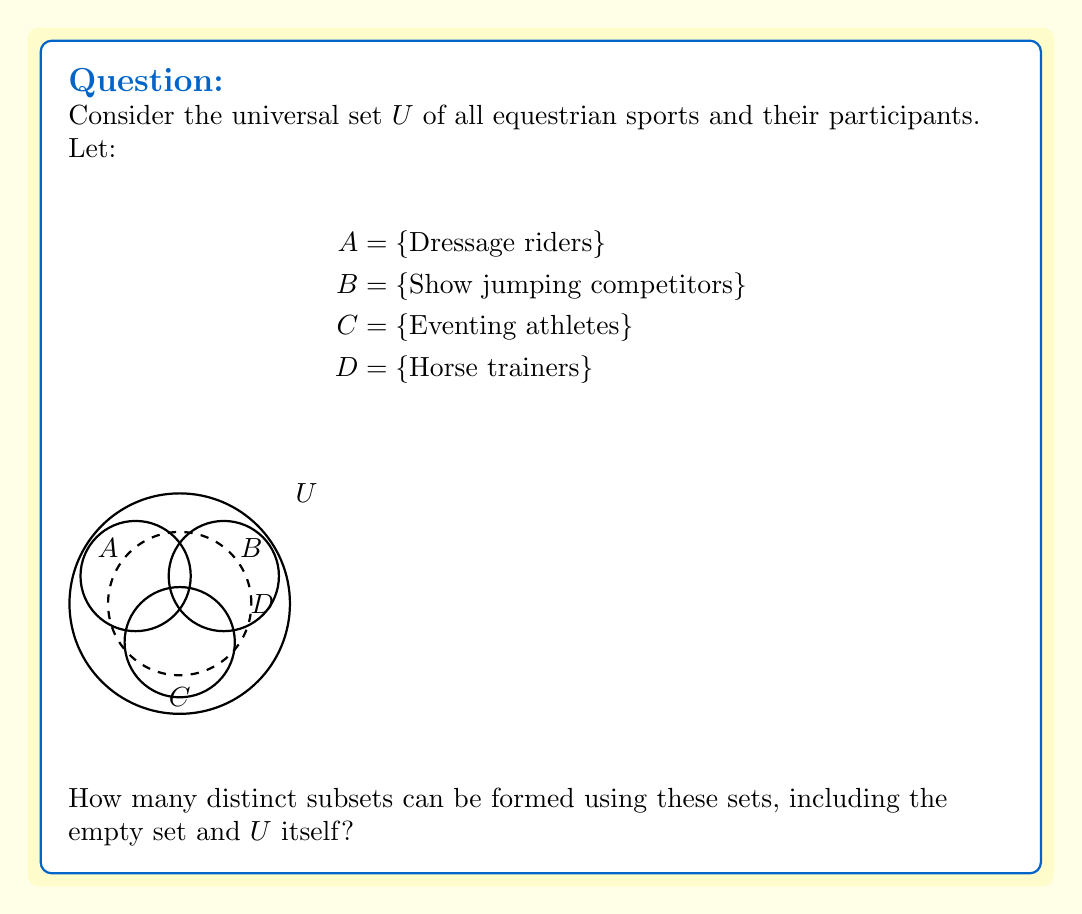Provide a solution to this math problem. To solve this problem, we need to use the concept of the power set in set theory.

Step 1: Identify the number of distinct sets we're working with.
We have 5 sets: $U$, $A$, $B$, $C$, and $D$.

Step 2: Understand that each of these sets can either be included or not included in a subset.

Step 3: Apply the formula for the number of subsets:
Number of subsets = $2^n$, where $n$ is the number of distinct sets.

In this case, $n = 5$.

Step 4: Calculate the result:
Number of subsets = $2^5 = 32$

This includes:
- The empty set $\emptyset$
- Each individual set ($U$, $A$, $B$, $C$, $D$)
- All possible combinations of these sets
- The universal set $U$ itself

Note: This calculation assumes that $U$ is considered as a separate set that can be included or excluded, rather than just being the universal set containing all others.
Answer: 32 